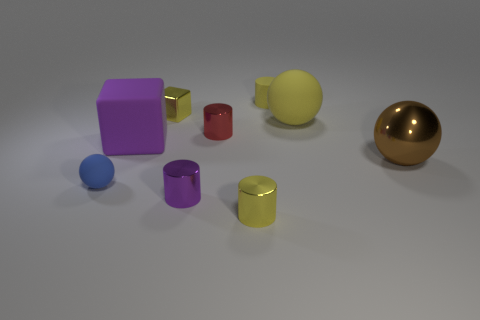How many cylinders have the same color as the metallic cube?
Keep it short and to the point. 2. What is the size of the rubber sphere that is the same color as the small block?
Provide a short and direct response. Large. There is a purple shiny object that is the same shape as the small red metal object; what size is it?
Give a very brief answer. Small. Is there anything else that is made of the same material as the purple cube?
Your answer should be very brief. Yes. How big is the yellow cylinder in front of the small cylinder that is behind the tiny red cylinder?
Your answer should be very brief. Small. Are there the same number of brown shiny objects that are on the left side of the tiny purple object and big red blocks?
Offer a very short reply. Yes. How many other objects are there of the same color as the tiny metal block?
Your answer should be compact. 3. Are there fewer small purple cylinders that are right of the brown sphere than blue rubber cubes?
Ensure brevity in your answer.  No. Is there a purple shiny object of the same size as the yellow metal cylinder?
Your answer should be very brief. Yes. There is a metallic block; is it the same color as the tiny shiny cylinder behind the small blue rubber ball?
Make the answer very short. No. 